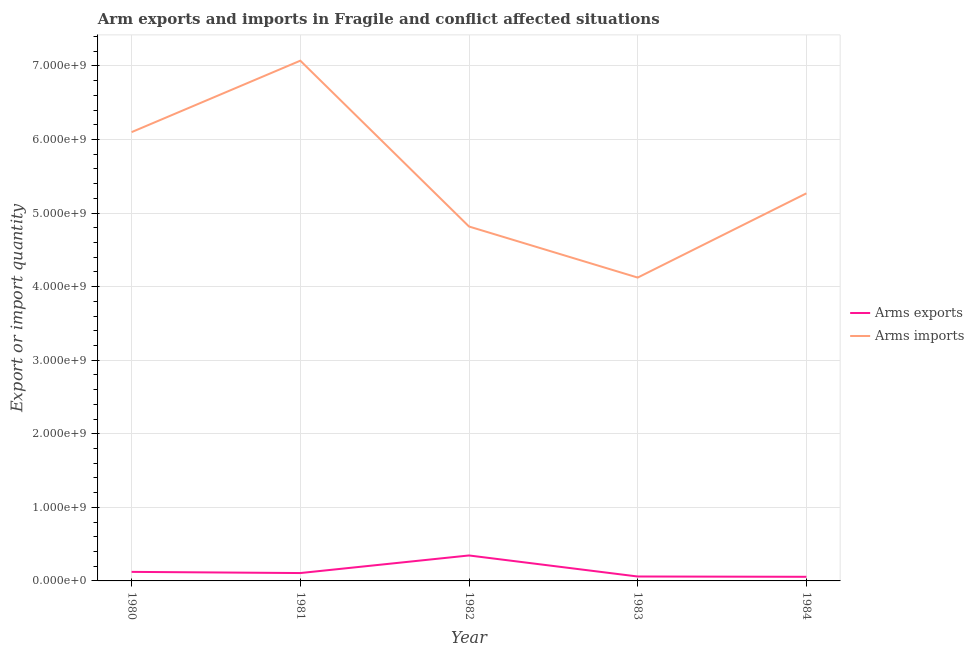How many different coloured lines are there?
Your answer should be compact. 2. Does the line corresponding to arms exports intersect with the line corresponding to arms imports?
Ensure brevity in your answer.  No. Is the number of lines equal to the number of legend labels?
Offer a very short reply. Yes. What is the arms exports in 1984?
Your answer should be very brief. 5.60e+07. Across all years, what is the maximum arms exports?
Your answer should be compact. 3.46e+08. Across all years, what is the minimum arms imports?
Your answer should be very brief. 4.12e+09. In which year was the arms imports maximum?
Offer a terse response. 1981. In which year was the arms exports minimum?
Your answer should be compact. 1984. What is the total arms imports in the graph?
Your response must be concise. 2.74e+1. What is the difference between the arms imports in 1982 and that in 1984?
Give a very brief answer. -4.51e+08. What is the difference between the arms exports in 1980 and the arms imports in 1983?
Provide a short and direct response. -4.00e+09. What is the average arms imports per year?
Your answer should be compact. 5.48e+09. In the year 1980, what is the difference between the arms exports and arms imports?
Offer a terse response. -5.98e+09. In how many years, is the arms imports greater than 4400000000?
Offer a very short reply. 4. What is the ratio of the arms imports in 1980 to that in 1982?
Provide a short and direct response. 1.27. Is the arms exports in 1980 less than that in 1982?
Give a very brief answer. Yes. What is the difference between the highest and the second highest arms exports?
Your answer should be very brief. 2.23e+08. What is the difference between the highest and the lowest arms exports?
Give a very brief answer. 2.90e+08. In how many years, is the arms imports greater than the average arms imports taken over all years?
Provide a succinct answer. 2. Is the sum of the arms imports in 1980 and 1984 greater than the maximum arms exports across all years?
Make the answer very short. Yes. Is the arms imports strictly less than the arms exports over the years?
Your answer should be very brief. No. How many lines are there?
Your response must be concise. 2. How many years are there in the graph?
Keep it short and to the point. 5. Are the values on the major ticks of Y-axis written in scientific E-notation?
Ensure brevity in your answer.  Yes. How many legend labels are there?
Provide a succinct answer. 2. What is the title of the graph?
Provide a short and direct response. Arm exports and imports in Fragile and conflict affected situations. Does "RDB nonconcessional" appear as one of the legend labels in the graph?
Make the answer very short. No. What is the label or title of the X-axis?
Your answer should be compact. Year. What is the label or title of the Y-axis?
Your answer should be very brief. Export or import quantity. What is the Export or import quantity in Arms exports in 1980?
Your response must be concise. 1.23e+08. What is the Export or import quantity of Arms imports in 1980?
Offer a very short reply. 6.10e+09. What is the Export or import quantity in Arms exports in 1981?
Offer a very short reply. 1.07e+08. What is the Export or import quantity in Arms imports in 1981?
Ensure brevity in your answer.  7.07e+09. What is the Export or import quantity of Arms exports in 1982?
Provide a succinct answer. 3.46e+08. What is the Export or import quantity of Arms imports in 1982?
Keep it short and to the point. 4.82e+09. What is the Export or import quantity in Arms exports in 1983?
Provide a short and direct response. 6.00e+07. What is the Export or import quantity in Arms imports in 1983?
Provide a succinct answer. 4.12e+09. What is the Export or import quantity of Arms exports in 1984?
Your answer should be compact. 5.60e+07. What is the Export or import quantity of Arms imports in 1984?
Ensure brevity in your answer.  5.27e+09. Across all years, what is the maximum Export or import quantity in Arms exports?
Your response must be concise. 3.46e+08. Across all years, what is the maximum Export or import quantity of Arms imports?
Provide a short and direct response. 7.07e+09. Across all years, what is the minimum Export or import quantity in Arms exports?
Keep it short and to the point. 5.60e+07. Across all years, what is the minimum Export or import quantity in Arms imports?
Ensure brevity in your answer.  4.12e+09. What is the total Export or import quantity in Arms exports in the graph?
Provide a short and direct response. 6.92e+08. What is the total Export or import quantity in Arms imports in the graph?
Your answer should be very brief. 2.74e+1. What is the difference between the Export or import quantity in Arms exports in 1980 and that in 1981?
Keep it short and to the point. 1.60e+07. What is the difference between the Export or import quantity of Arms imports in 1980 and that in 1981?
Keep it short and to the point. -9.71e+08. What is the difference between the Export or import quantity of Arms exports in 1980 and that in 1982?
Make the answer very short. -2.23e+08. What is the difference between the Export or import quantity of Arms imports in 1980 and that in 1982?
Offer a very short reply. 1.28e+09. What is the difference between the Export or import quantity of Arms exports in 1980 and that in 1983?
Your answer should be very brief. 6.30e+07. What is the difference between the Export or import quantity in Arms imports in 1980 and that in 1983?
Your answer should be very brief. 1.98e+09. What is the difference between the Export or import quantity in Arms exports in 1980 and that in 1984?
Make the answer very short. 6.70e+07. What is the difference between the Export or import quantity in Arms imports in 1980 and that in 1984?
Provide a succinct answer. 8.32e+08. What is the difference between the Export or import quantity in Arms exports in 1981 and that in 1982?
Provide a short and direct response. -2.39e+08. What is the difference between the Export or import quantity in Arms imports in 1981 and that in 1982?
Offer a terse response. 2.25e+09. What is the difference between the Export or import quantity of Arms exports in 1981 and that in 1983?
Your answer should be very brief. 4.70e+07. What is the difference between the Export or import quantity of Arms imports in 1981 and that in 1983?
Make the answer very short. 2.95e+09. What is the difference between the Export or import quantity of Arms exports in 1981 and that in 1984?
Provide a succinct answer. 5.10e+07. What is the difference between the Export or import quantity in Arms imports in 1981 and that in 1984?
Keep it short and to the point. 1.80e+09. What is the difference between the Export or import quantity of Arms exports in 1982 and that in 1983?
Make the answer very short. 2.86e+08. What is the difference between the Export or import quantity in Arms imports in 1982 and that in 1983?
Your answer should be very brief. 6.94e+08. What is the difference between the Export or import quantity in Arms exports in 1982 and that in 1984?
Provide a short and direct response. 2.90e+08. What is the difference between the Export or import quantity in Arms imports in 1982 and that in 1984?
Offer a very short reply. -4.51e+08. What is the difference between the Export or import quantity in Arms imports in 1983 and that in 1984?
Your answer should be compact. -1.14e+09. What is the difference between the Export or import quantity of Arms exports in 1980 and the Export or import quantity of Arms imports in 1981?
Your answer should be very brief. -6.95e+09. What is the difference between the Export or import quantity of Arms exports in 1980 and the Export or import quantity of Arms imports in 1982?
Keep it short and to the point. -4.69e+09. What is the difference between the Export or import quantity of Arms exports in 1980 and the Export or import quantity of Arms imports in 1983?
Make the answer very short. -4.00e+09. What is the difference between the Export or import quantity of Arms exports in 1980 and the Export or import quantity of Arms imports in 1984?
Your answer should be compact. -5.14e+09. What is the difference between the Export or import quantity of Arms exports in 1981 and the Export or import quantity of Arms imports in 1982?
Your answer should be compact. -4.71e+09. What is the difference between the Export or import quantity of Arms exports in 1981 and the Export or import quantity of Arms imports in 1983?
Ensure brevity in your answer.  -4.02e+09. What is the difference between the Export or import quantity of Arms exports in 1981 and the Export or import quantity of Arms imports in 1984?
Offer a very short reply. -5.16e+09. What is the difference between the Export or import quantity of Arms exports in 1982 and the Export or import quantity of Arms imports in 1983?
Provide a succinct answer. -3.78e+09. What is the difference between the Export or import quantity in Arms exports in 1982 and the Export or import quantity in Arms imports in 1984?
Offer a very short reply. -4.92e+09. What is the difference between the Export or import quantity in Arms exports in 1983 and the Export or import quantity in Arms imports in 1984?
Your response must be concise. -5.21e+09. What is the average Export or import quantity of Arms exports per year?
Your answer should be very brief. 1.38e+08. What is the average Export or import quantity of Arms imports per year?
Offer a terse response. 5.48e+09. In the year 1980, what is the difference between the Export or import quantity of Arms exports and Export or import quantity of Arms imports?
Your response must be concise. -5.98e+09. In the year 1981, what is the difference between the Export or import quantity of Arms exports and Export or import quantity of Arms imports?
Ensure brevity in your answer.  -6.96e+09. In the year 1982, what is the difference between the Export or import quantity of Arms exports and Export or import quantity of Arms imports?
Make the answer very short. -4.47e+09. In the year 1983, what is the difference between the Export or import quantity in Arms exports and Export or import quantity in Arms imports?
Keep it short and to the point. -4.06e+09. In the year 1984, what is the difference between the Export or import quantity in Arms exports and Export or import quantity in Arms imports?
Offer a very short reply. -5.21e+09. What is the ratio of the Export or import quantity in Arms exports in 1980 to that in 1981?
Your response must be concise. 1.15. What is the ratio of the Export or import quantity in Arms imports in 1980 to that in 1981?
Offer a terse response. 0.86. What is the ratio of the Export or import quantity of Arms exports in 1980 to that in 1982?
Offer a terse response. 0.36. What is the ratio of the Export or import quantity of Arms imports in 1980 to that in 1982?
Offer a very short reply. 1.27. What is the ratio of the Export or import quantity in Arms exports in 1980 to that in 1983?
Provide a succinct answer. 2.05. What is the ratio of the Export or import quantity of Arms imports in 1980 to that in 1983?
Your response must be concise. 1.48. What is the ratio of the Export or import quantity in Arms exports in 1980 to that in 1984?
Give a very brief answer. 2.2. What is the ratio of the Export or import quantity of Arms imports in 1980 to that in 1984?
Provide a short and direct response. 1.16. What is the ratio of the Export or import quantity of Arms exports in 1981 to that in 1982?
Provide a short and direct response. 0.31. What is the ratio of the Export or import quantity of Arms imports in 1981 to that in 1982?
Provide a succinct answer. 1.47. What is the ratio of the Export or import quantity of Arms exports in 1981 to that in 1983?
Offer a very short reply. 1.78. What is the ratio of the Export or import quantity of Arms imports in 1981 to that in 1983?
Give a very brief answer. 1.72. What is the ratio of the Export or import quantity in Arms exports in 1981 to that in 1984?
Keep it short and to the point. 1.91. What is the ratio of the Export or import quantity of Arms imports in 1981 to that in 1984?
Provide a succinct answer. 1.34. What is the ratio of the Export or import quantity of Arms exports in 1982 to that in 1983?
Your response must be concise. 5.77. What is the ratio of the Export or import quantity of Arms imports in 1982 to that in 1983?
Give a very brief answer. 1.17. What is the ratio of the Export or import quantity in Arms exports in 1982 to that in 1984?
Give a very brief answer. 6.18. What is the ratio of the Export or import quantity in Arms imports in 1982 to that in 1984?
Your response must be concise. 0.91. What is the ratio of the Export or import quantity of Arms exports in 1983 to that in 1984?
Your response must be concise. 1.07. What is the ratio of the Export or import quantity of Arms imports in 1983 to that in 1984?
Provide a succinct answer. 0.78. What is the difference between the highest and the second highest Export or import quantity in Arms exports?
Give a very brief answer. 2.23e+08. What is the difference between the highest and the second highest Export or import quantity in Arms imports?
Offer a terse response. 9.71e+08. What is the difference between the highest and the lowest Export or import quantity of Arms exports?
Your answer should be very brief. 2.90e+08. What is the difference between the highest and the lowest Export or import quantity of Arms imports?
Offer a terse response. 2.95e+09. 